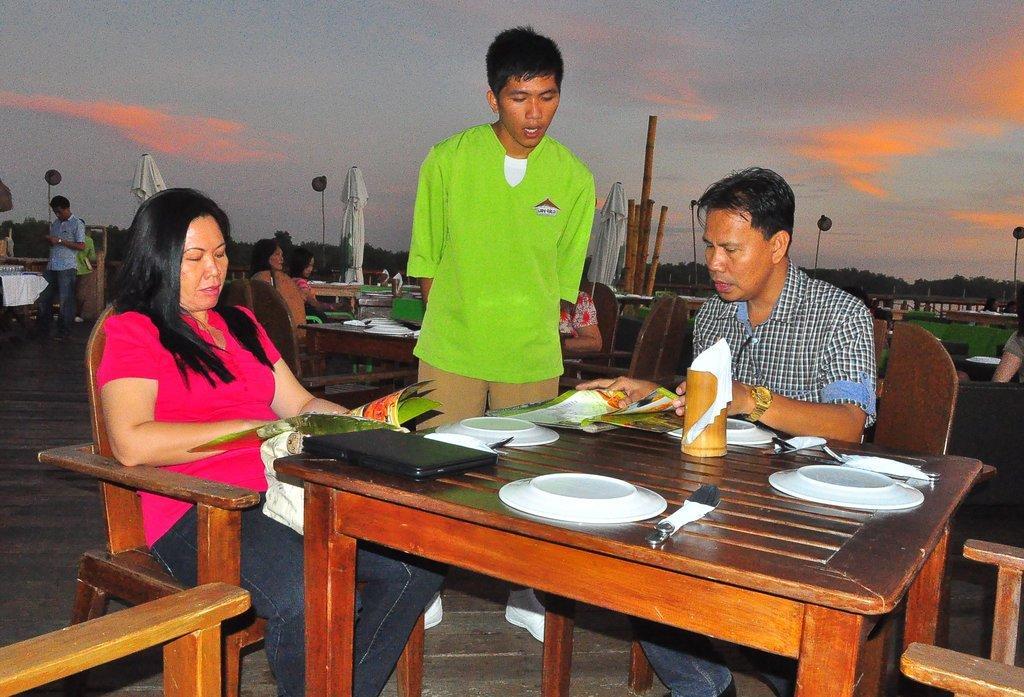Can you describe this image briefly? In this image I can see a group of people among them few people are sitting on a chair in front of a table and few people are standing on the ground. On the table I can see there are few plates and other objects on it. 